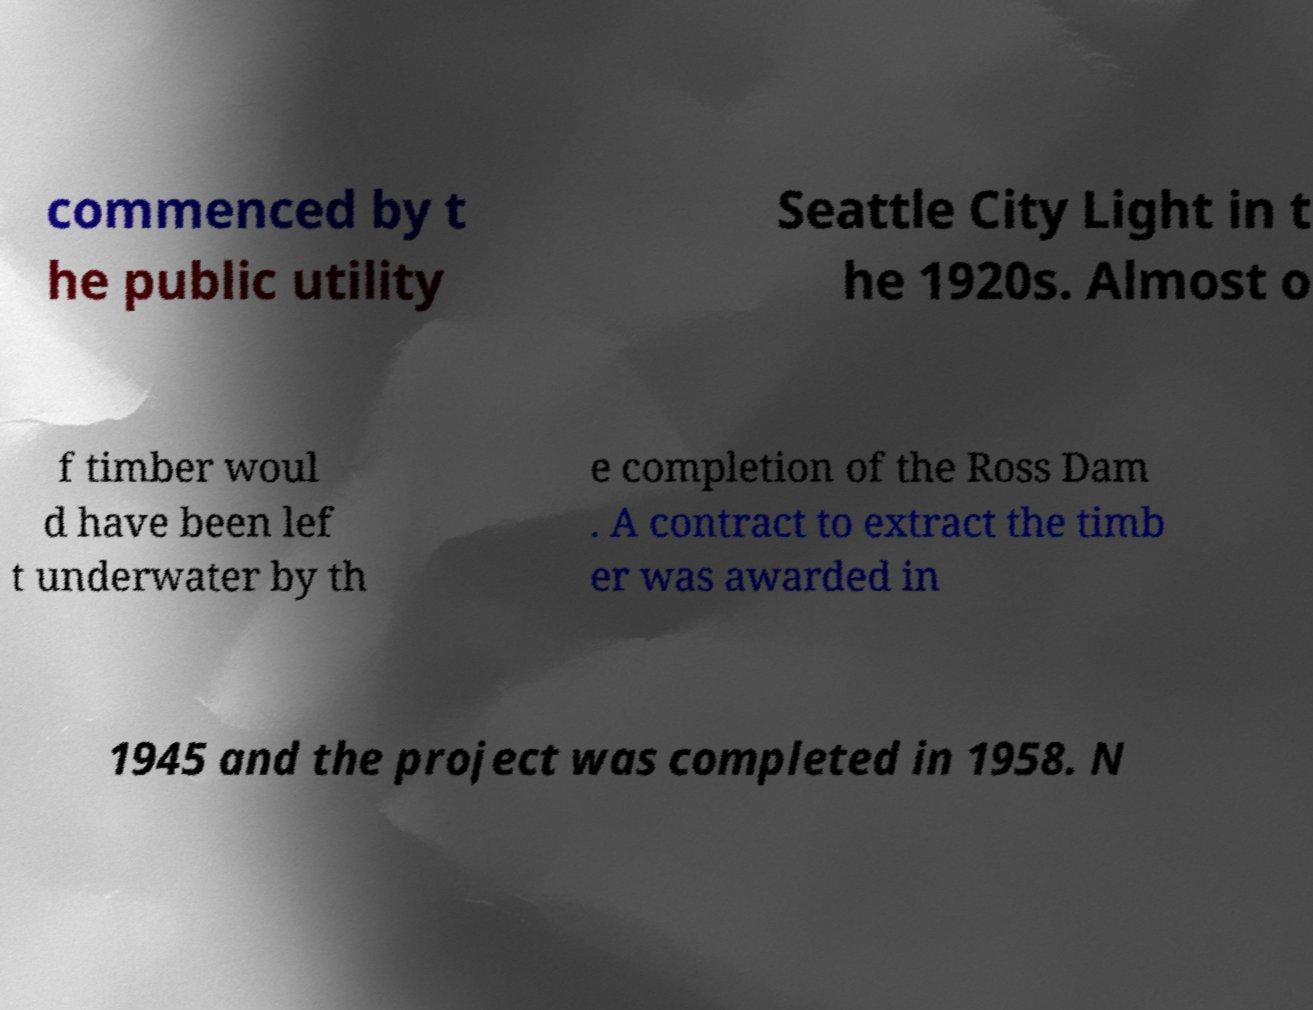For documentation purposes, I need the text within this image transcribed. Could you provide that? commenced by t he public utility Seattle City Light in t he 1920s. Almost o f timber woul d have been lef t underwater by th e completion of the Ross Dam . A contract to extract the timb er was awarded in 1945 and the project was completed in 1958. N 